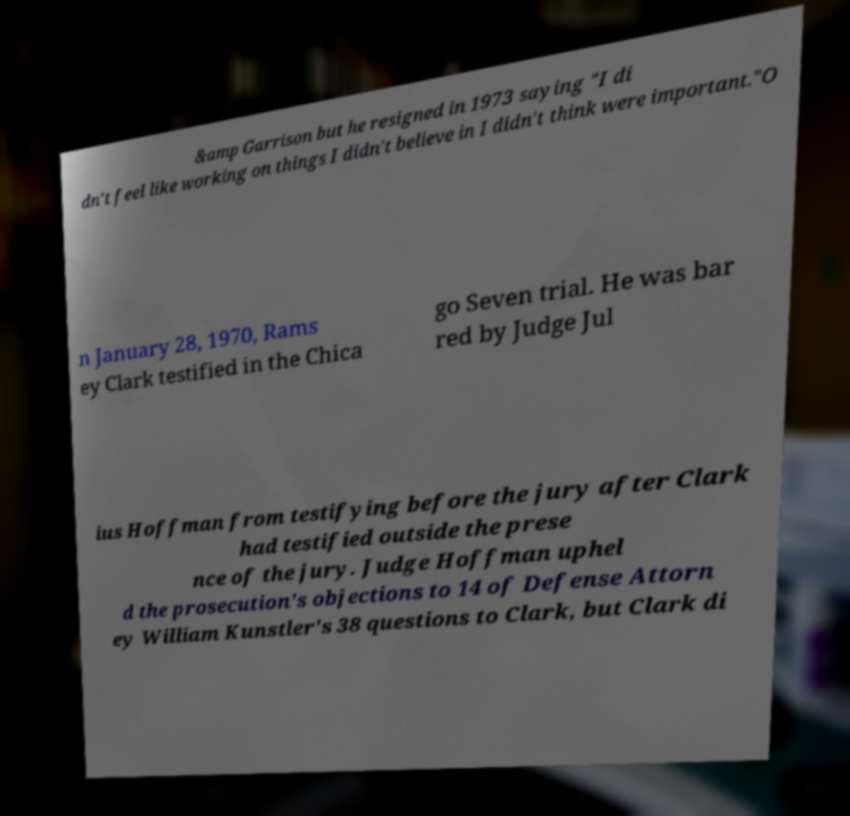I need the written content from this picture converted into text. Can you do that? &amp Garrison but he resigned in 1973 saying "I di dn't feel like working on things I didn't believe in I didn't think were important."O n January 28, 1970, Rams ey Clark testified in the Chica go Seven trial. He was bar red by Judge Jul ius Hoffman from testifying before the jury after Clark had testified outside the prese nce of the jury. Judge Hoffman uphel d the prosecution's objections to 14 of Defense Attorn ey William Kunstler's 38 questions to Clark, but Clark di 